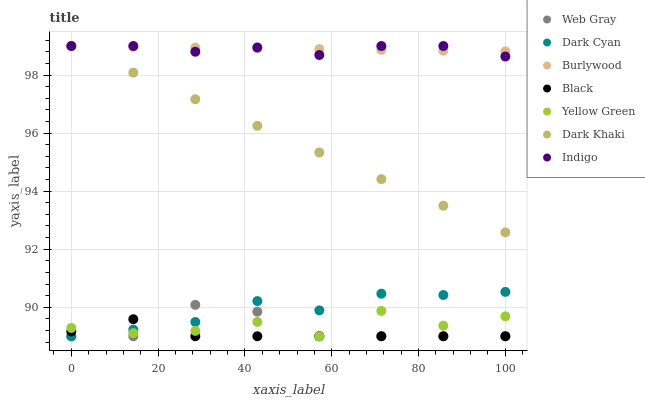Does Black have the minimum area under the curve?
Answer yes or no. Yes. Does Burlywood have the maximum area under the curve?
Answer yes or no. Yes. Does Indigo have the minimum area under the curve?
Answer yes or no. No. Does Indigo have the maximum area under the curve?
Answer yes or no. No. Is Dark Khaki the smoothest?
Answer yes or no. Yes. Is Yellow Green the roughest?
Answer yes or no. Yes. Is Indigo the smoothest?
Answer yes or no. No. Is Indigo the roughest?
Answer yes or no. No. Does Web Gray have the lowest value?
Answer yes or no. Yes. Does Indigo have the lowest value?
Answer yes or no. No. Does Dark Khaki have the highest value?
Answer yes or no. Yes. Does Yellow Green have the highest value?
Answer yes or no. No. Is Web Gray less than Dark Khaki?
Answer yes or no. Yes. Is Dark Khaki greater than Dark Cyan?
Answer yes or no. Yes. Does Dark Khaki intersect Burlywood?
Answer yes or no. Yes. Is Dark Khaki less than Burlywood?
Answer yes or no. No. Is Dark Khaki greater than Burlywood?
Answer yes or no. No. Does Web Gray intersect Dark Khaki?
Answer yes or no. No. 